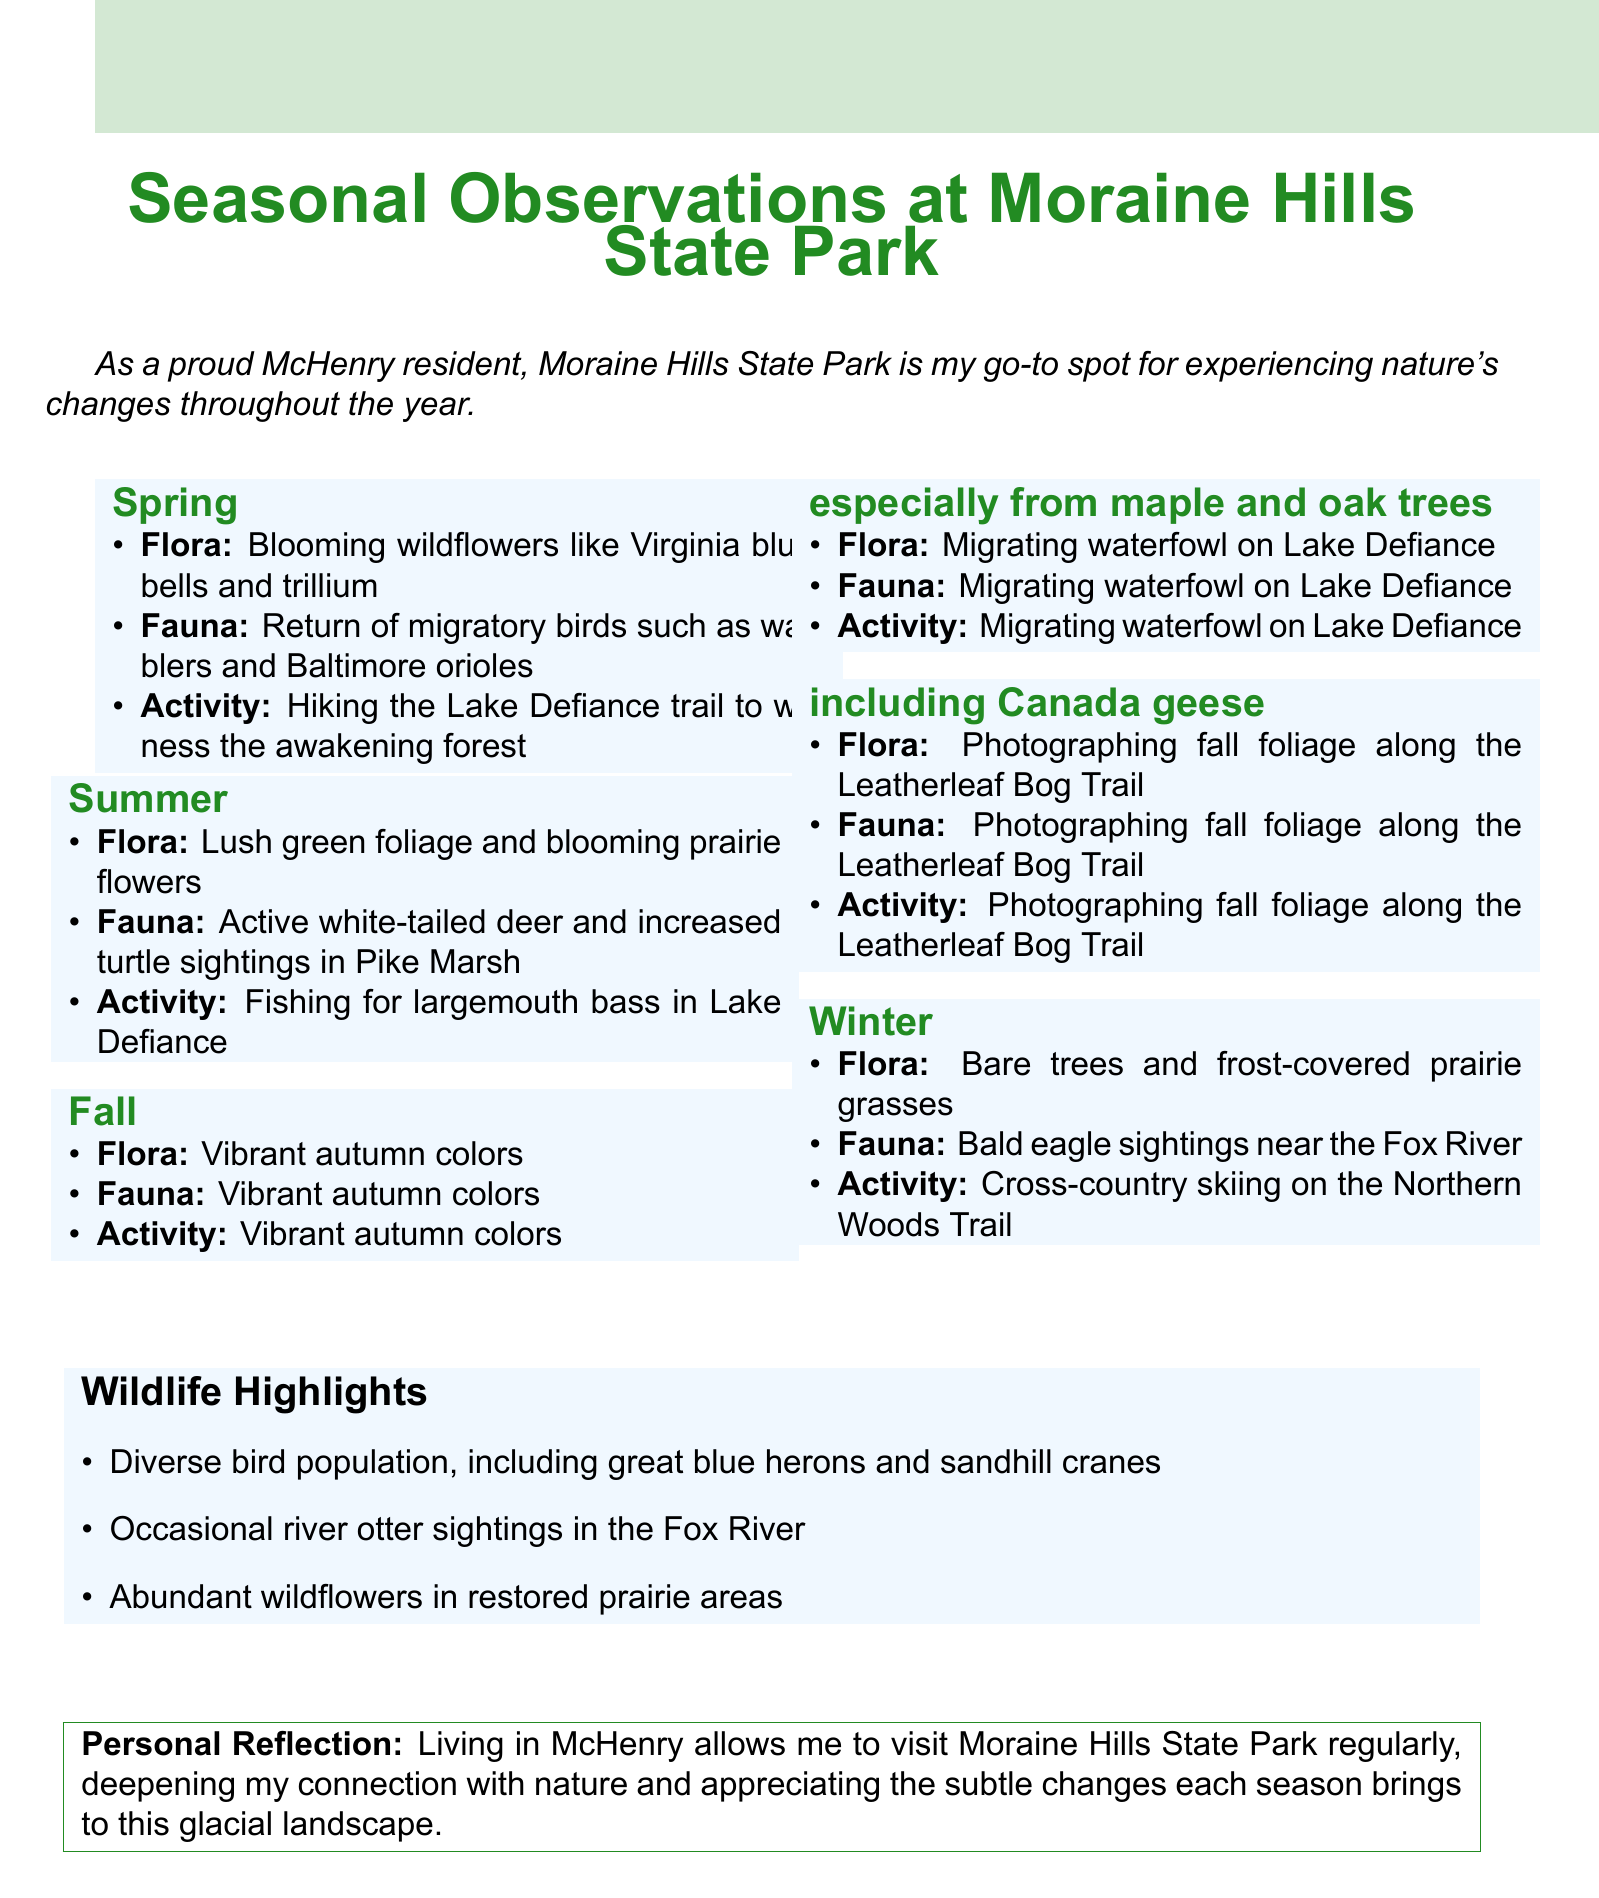What is the title of the document? The title of the document is explicitly stated at the beginning of the content provided.
Answer: Seasonal Observations at Moraine Hills State Park What migratory birds return in spring? The document lists specific migratory birds that return during spring, found in the seasonal observations section.
Answer: Warblers and Baltimore orioles What activity is suggested for summer? The document indicates a recommended activity for summer, providing insight into local recreation options.
Answer: Fishing for largemouth bass in Lake Defiance Which tree species shows vibrant colors in fall? The document specifies tree species known for their autumn colors in the fall seasonal observations.
Answer: Maple and oak trees What wildlife can occasionally be spotted in the Fox River? The document mentions specific wildlife sightings in the context of the park's fauna.
Answer: River otters In which season does one witness frost-covered prairie grasses? The document outlines specific characteristics of each season, including flora descriptions.
Answer: Winter How does living in McHenry enhance the author’s experience with nature? The document provides a personal reflection on the author's connection to the park and nature.
Answer: Deepening my connection with nature What is the main flora observed in spring? The document reflects on unique flora observed in Moraine Hills State Park during the spring season.
Answer: Blooming wildflowers like Virginia bluebells and trillium 